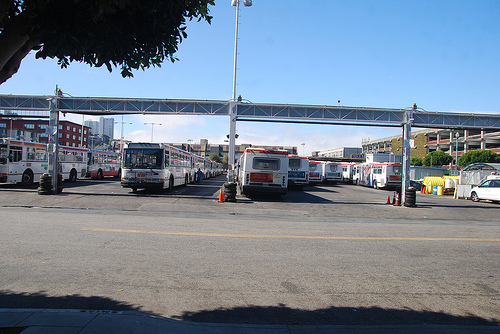Are there both cars and buses in this picture? Yes, there are. The picture features a diverse collection of vehicles including both cars and buses, showcasing a busy transport area. 